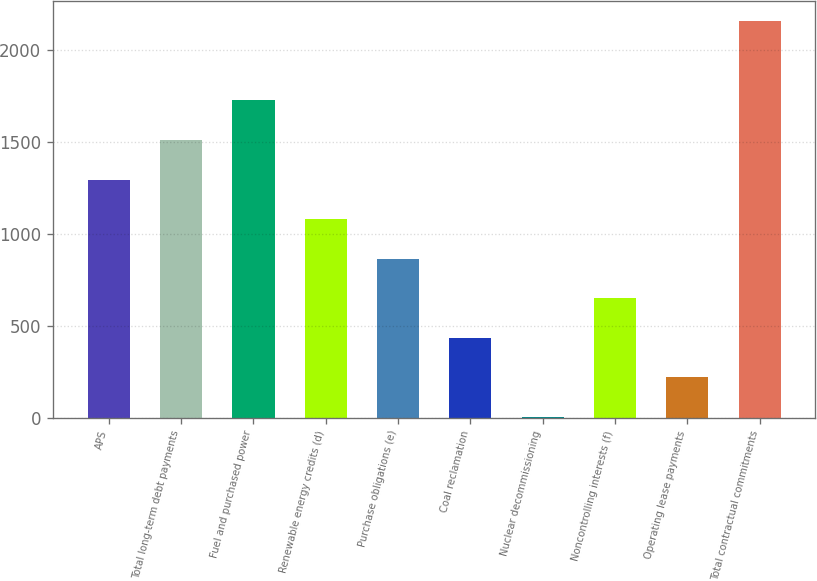<chart> <loc_0><loc_0><loc_500><loc_500><bar_chart><fcel>APS<fcel>Total long-term debt payments<fcel>Fuel and purchased power<fcel>Renewable energy credits (d)<fcel>Purchase obligations (e)<fcel>Coal reclamation<fcel>Nuclear decommissioning<fcel>Noncontrolling interests (f)<fcel>Operating lease payments<fcel>Total contractual commitments<nl><fcel>1297.4<fcel>1512.8<fcel>1728.2<fcel>1082<fcel>866.6<fcel>435.8<fcel>5<fcel>651.2<fcel>220.4<fcel>2159<nl></chart> 